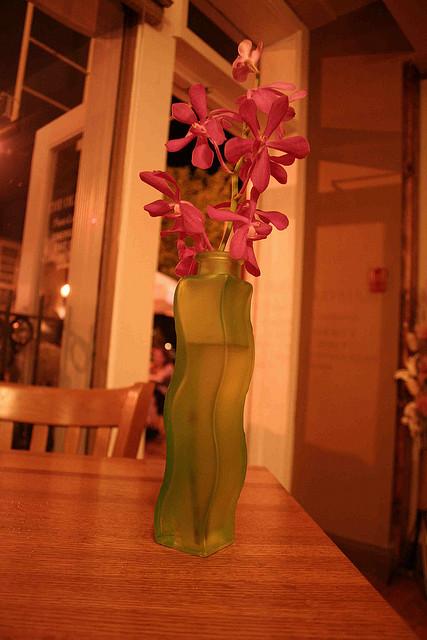What is on the table?
Keep it brief. Vase. What is the table made of?
Concise answer only. Wood. Are there chandeliers in the picture?
Write a very short answer. No. What color is the vase?
Give a very brief answer. Green. How many chairs are visible?
Quick response, please. 1. 